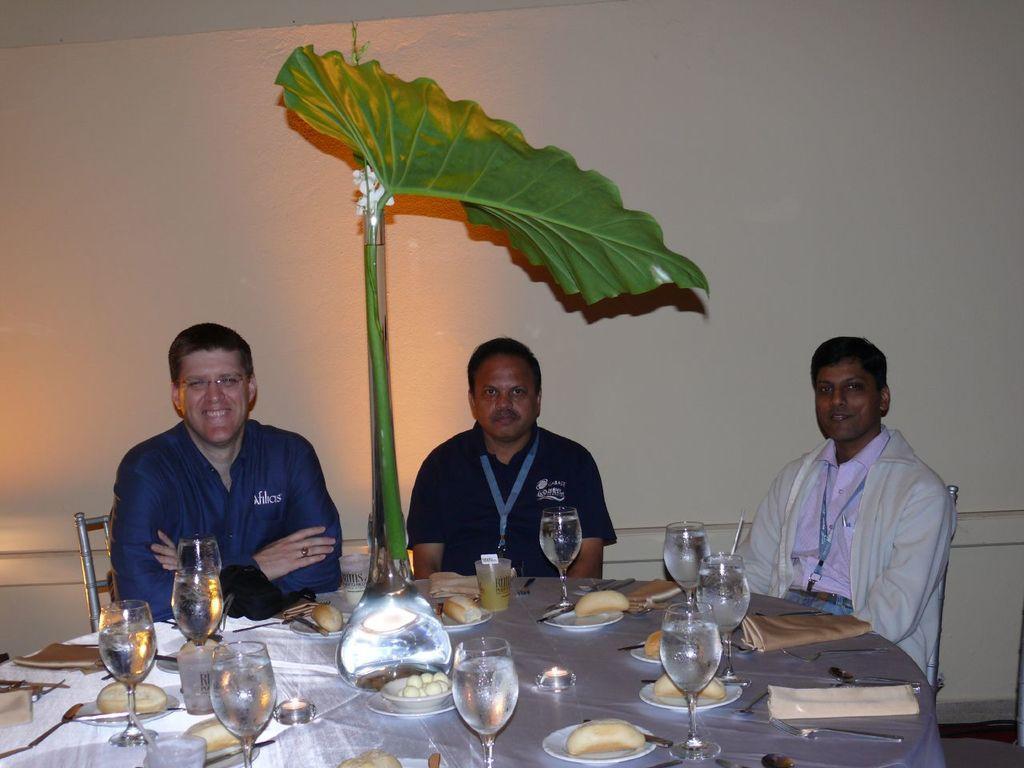In one or two sentences, can you explain what this image depicts? This picture shows three men seated on the chairs we see few glasses and plates on the table and we see a plant on the side 